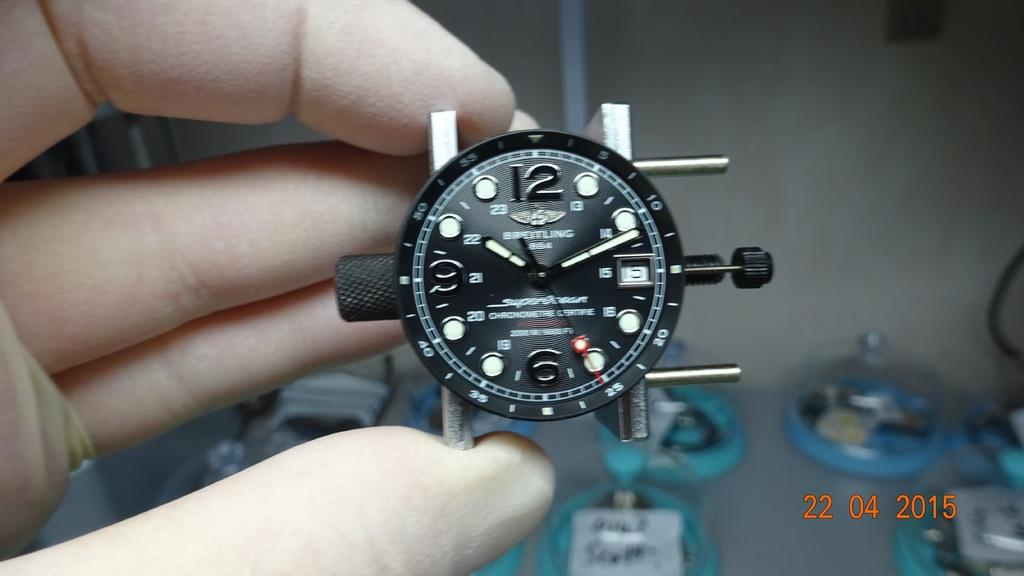<image>
Write a terse but informative summary of the picture. Breitling women's watch with no straps and winding knobs on opposite sides of watch face, "Chronometre Certife". 